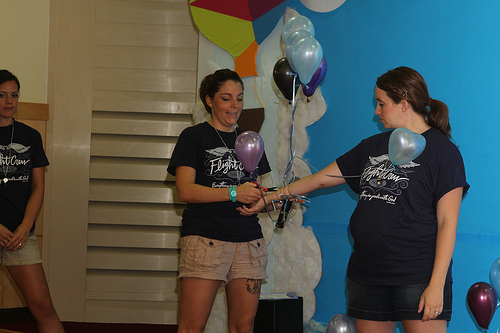<image>
Is the woman behind the wall? No. The woman is not behind the wall. From this viewpoint, the woman appears to be positioned elsewhere in the scene. 